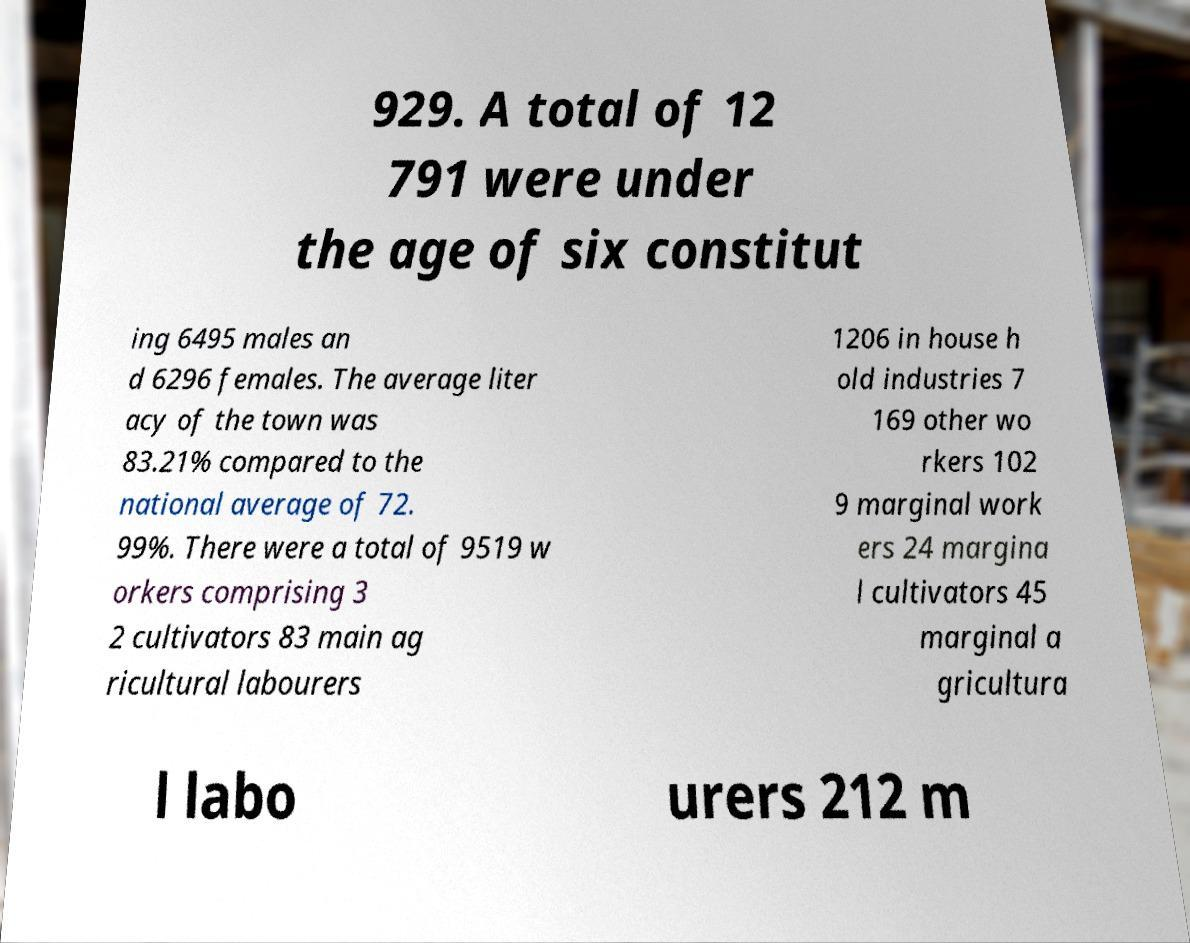I need the written content from this picture converted into text. Can you do that? 929. A total of 12 791 were under the age of six constitut ing 6495 males an d 6296 females. The average liter acy of the town was 83.21% compared to the national average of 72. 99%. There were a total of 9519 w orkers comprising 3 2 cultivators 83 main ag ricultural labourers 1206 in house h old industries 7 169 other wo rkers 102 9 marginal work ers 24 margina l cultivators 45 marginal a gricultura l labo urers 212 m 